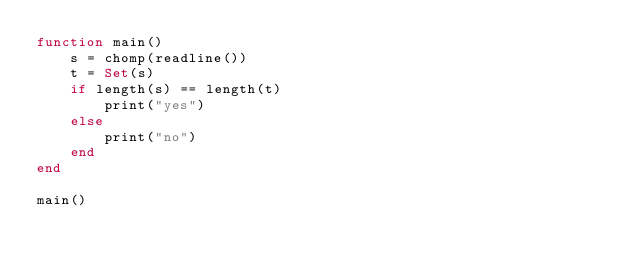<code> <loc_0><loc_0><loc_500><loc_500><_Julia_>function main()
	s = chomp(readline())
	t = Set(s)
	if length(s) == length(t)
		print("yes")
	else
		print("no")
	end
end

main()</code> 